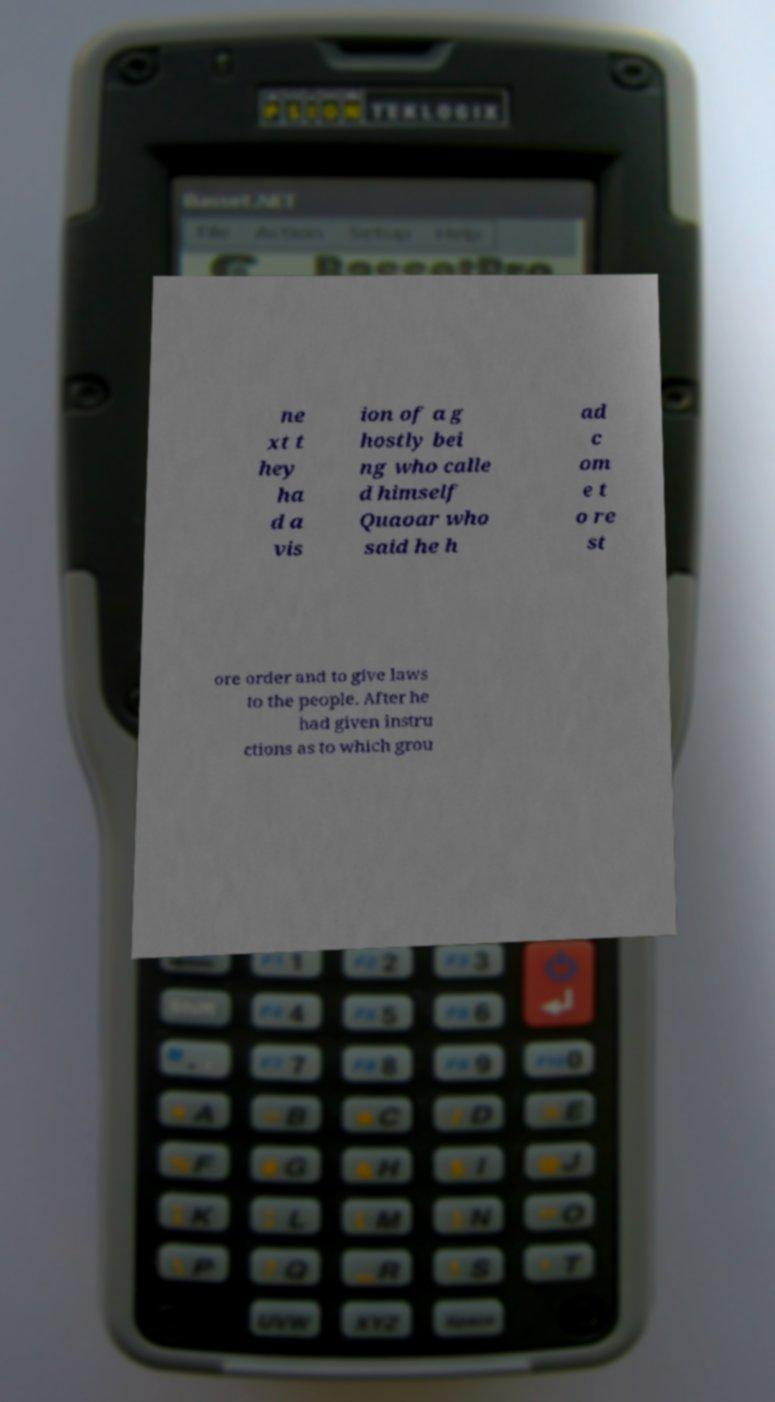Could you assist in decoding the text presented in this image and type it out clearly? ne xt t hey ha d a vis ion of a g hostly bei ng who calle d himself Quaoar who said he h ad c om e t o re st ore order and to give laws to the people. After he had given instru ctions as to which grou 